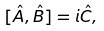<formula> <loc_0><loc_0><loc_500><loc_500>[ \hat { A } , \hat { B } ] = i \hat { C } ,</formula> 